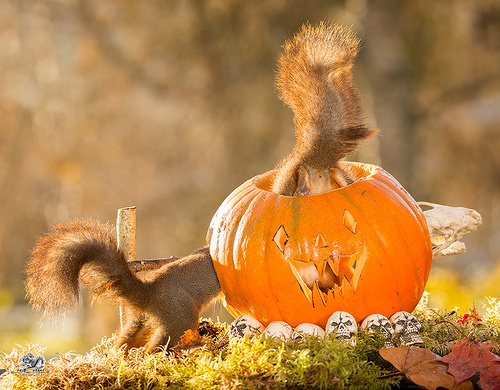<image>
Is there a squirrel in the pumpkin? Yes. The squirrel is contained within or inside the pumpkin, showing a containment relationship. 